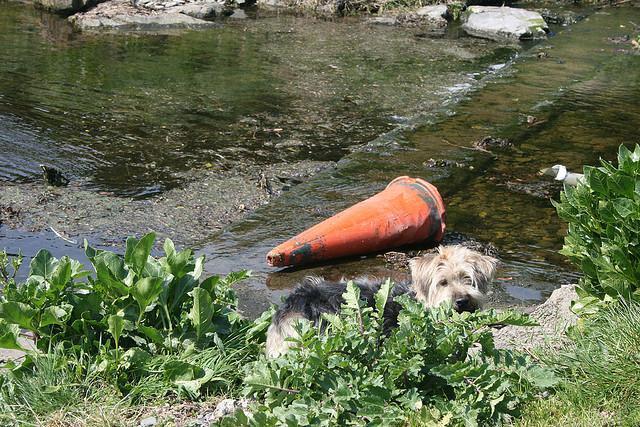How many dogs are there?
Give a very brief answer. 1. How many people are wearing pink helmets?
Give a very brief answer. 0. 